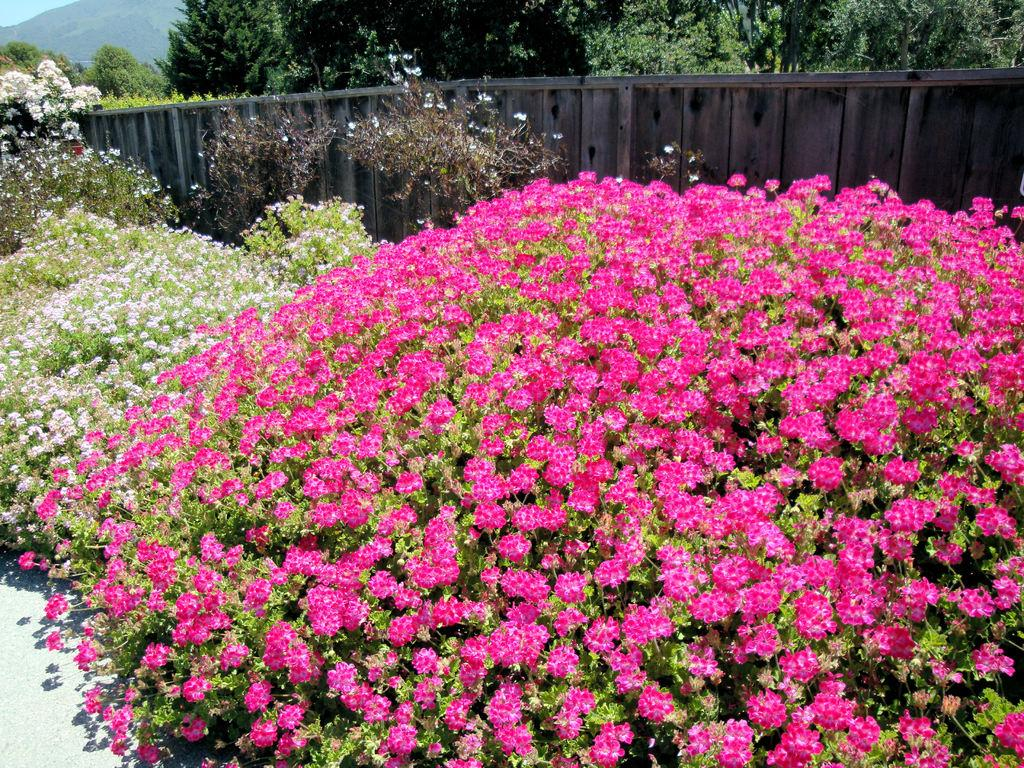What colors are the flowers in the image? The flowers in the image are in pink and white colors. What type of vegetation can be seen besides the flowers? There are trees in the image. What is the purpose of the structure visible in the image? The fencing in the image serves as a barrier or boundary. What geographical feature is present in the image? There is a mountain in the image. Does the existence of the flowers in the image prove the existence of a unicorn? No, the existence of the flowers in the image does not prove the existence of a unicorn, as there is no mention or indication of a unicorn in the image or the provided facts. 